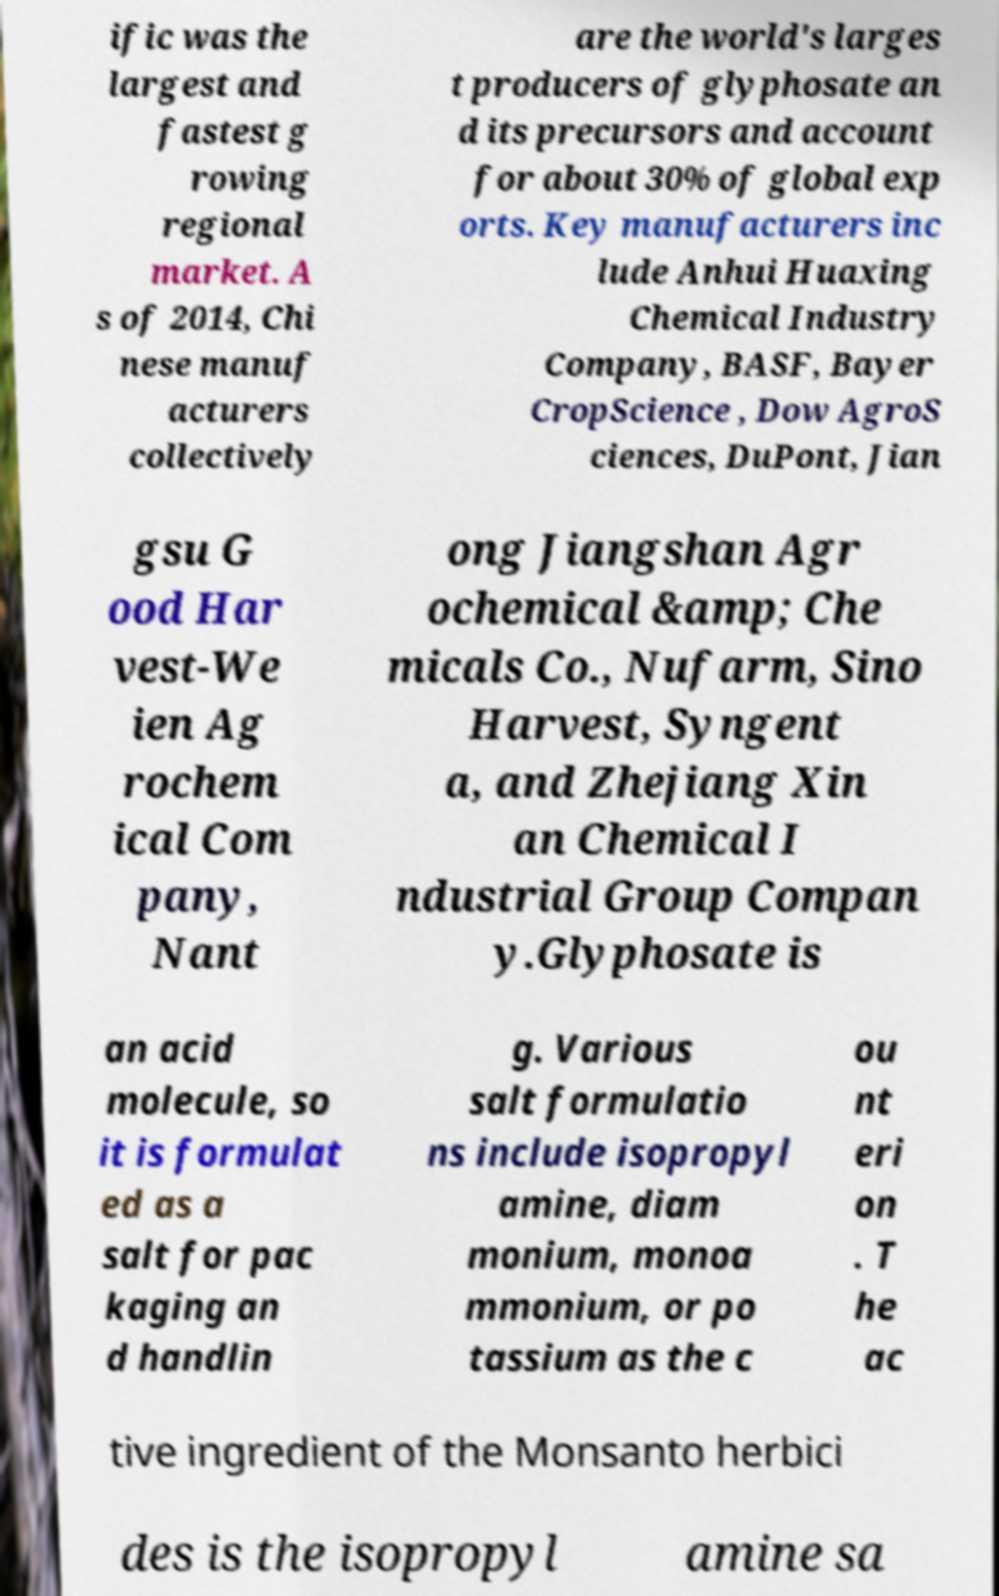Please read and relay the text visible in this image. What does it say? ific was the largest and fastest g rowing regional market. A s of 2014, Chi nese manuf acturers collectively are the world's larges t producers of glyphosate an d its precursors and account for about 30% of global exp orts. Key manufacturers inc lude Anhui Huaxing Chemical Industry Company, BASF, Bayer CropScience , Dow AgroS ciences, DuPont, Jian gsu G ood Har vest-We ien Ag rochem ical Com pany, Nant ong Jiangshan Agr ochemical &amp; Che micals Co., Nufarm, Sino Harvest, Syngent a, and Zhejiang Xin an Chemical I ndustrial Group Compan y.Glyphosate is an acid molecule, so it is formulat ed as a salt for pac kaging an d handlin g. Various salt formulatio ns include isopropyl amine, diam monium, monoa mmonium, or po tassium as the c ou nt eri on . T he ac tive ingredient of the Monsanto herbici des is the isopropyl amine sa 